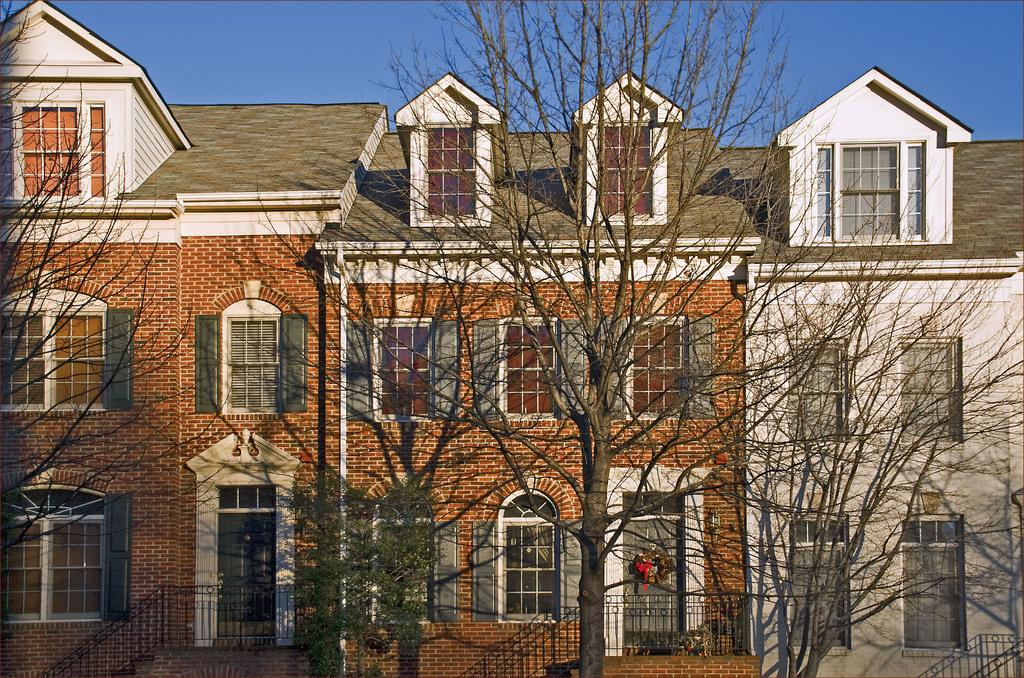What is the main structure in the image? There is a building in the image. What can be seen in front of the building? There are trees in front of the building. What part of the natural environment is visible in the image? The sky is visible in the background of the image. How many cakes are on the roof of the building in the image? There are no cakes visible on the roof of the building in the image. What type of rose can be seen growing near the building? There are no roses present in the image; only trees are visible in front of the building. 